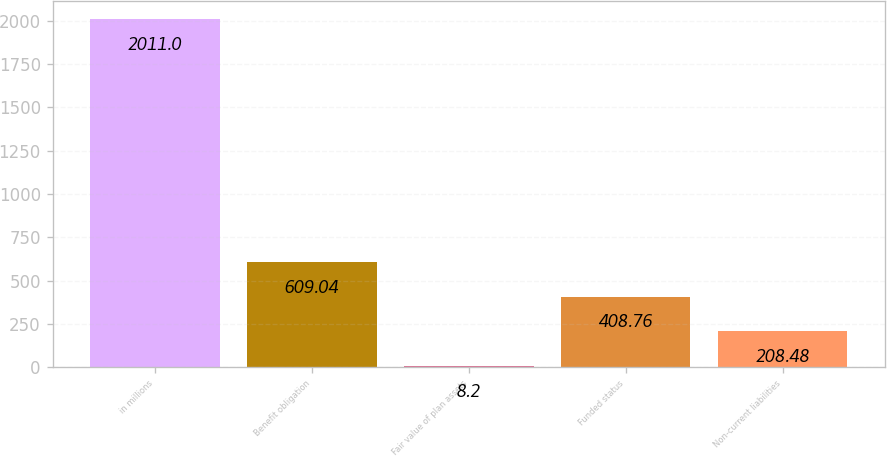Convert chart to OTSL. <chart><loc_0><loc_0><loc_500><loc_500><bar_chart><fcel>in millions<fcel>Benefit obligation<fcel>Fair value of plan assets<fcel>Funded status<fcel>Non-current liabilities<nl><fcel>2011<fcel>609.04<fcel>8.2<fcel>408.76<fcel>208.48<nl></chart> 